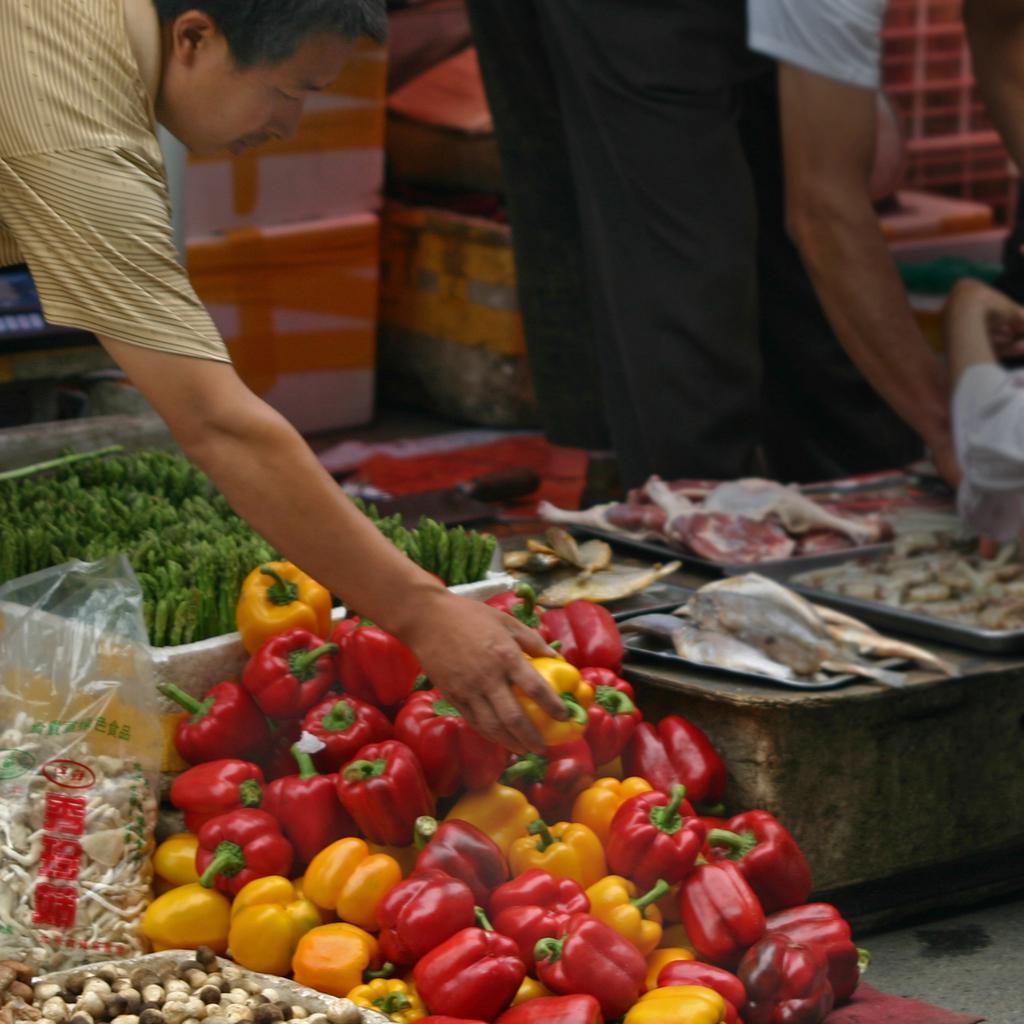Could you give a brief overview of what you see in this image? In this image, I can see a person holding a bell pepper. There are bunch of bell peppers, meat and few other vegetables. On the right side of the image, I can see a person´s hand. In the background, there are thermocol storage boxes, objects and the legs of two persons. 